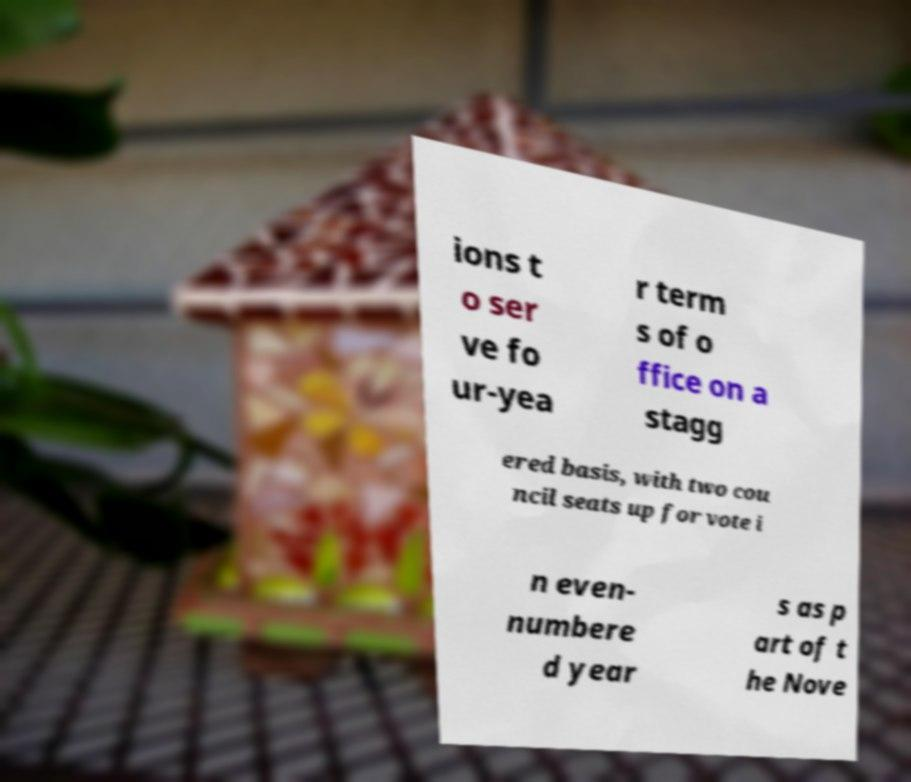What messages or text are displayed in this image? I need them in a readable, typed format. ions t o ser ve fo ur-yea r term s of o ffice on a stagg ered basis, with two cou ncil seats up for vote i n even- numbere d year s as p art of t he Nove 